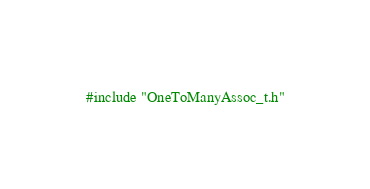Convert code to text. <code><loc_0><loc_0><loc_500><loc_500><_Cuda_>#include "OneToManyAssoc_t.h"
</code> 